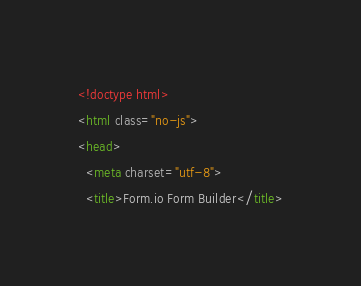<code> <loc_0><loc_0><loc_500><loc_500><_HTML_><!doctype html>
<html class="no-js">
<head>
  <meta charset="utf-8">
  <title>Form.io Form Builder</title></code> 